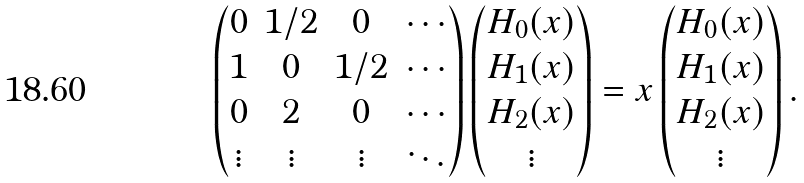Convert formula to latex. <formula><loc_0><loc_0><loc_500><loc_500>\begin{pmatrix} 0 & 1 / 2 & 0 & \cdots \\ 1 & 0 & 1 / 2 & \cdots \\ 0 & 2 & 0 & \cdots \\ \vdots & \vdots & \vdots & \ddots \\ \end{pmatrix} \begin{pmatrix} H _ { 0 } ( x ) \\ H _ { 1 } ( x ) \\ H _ { 2 } ( x ) \\ \vdots \end{pmatrix} = x \begin{pmatrix} H _ { 0 } ( x ) \\ H _ { 1 } ( x ) \\ H _ { 2 } ( x ) \\ \vdots \end{pmatrix} .</formula> 